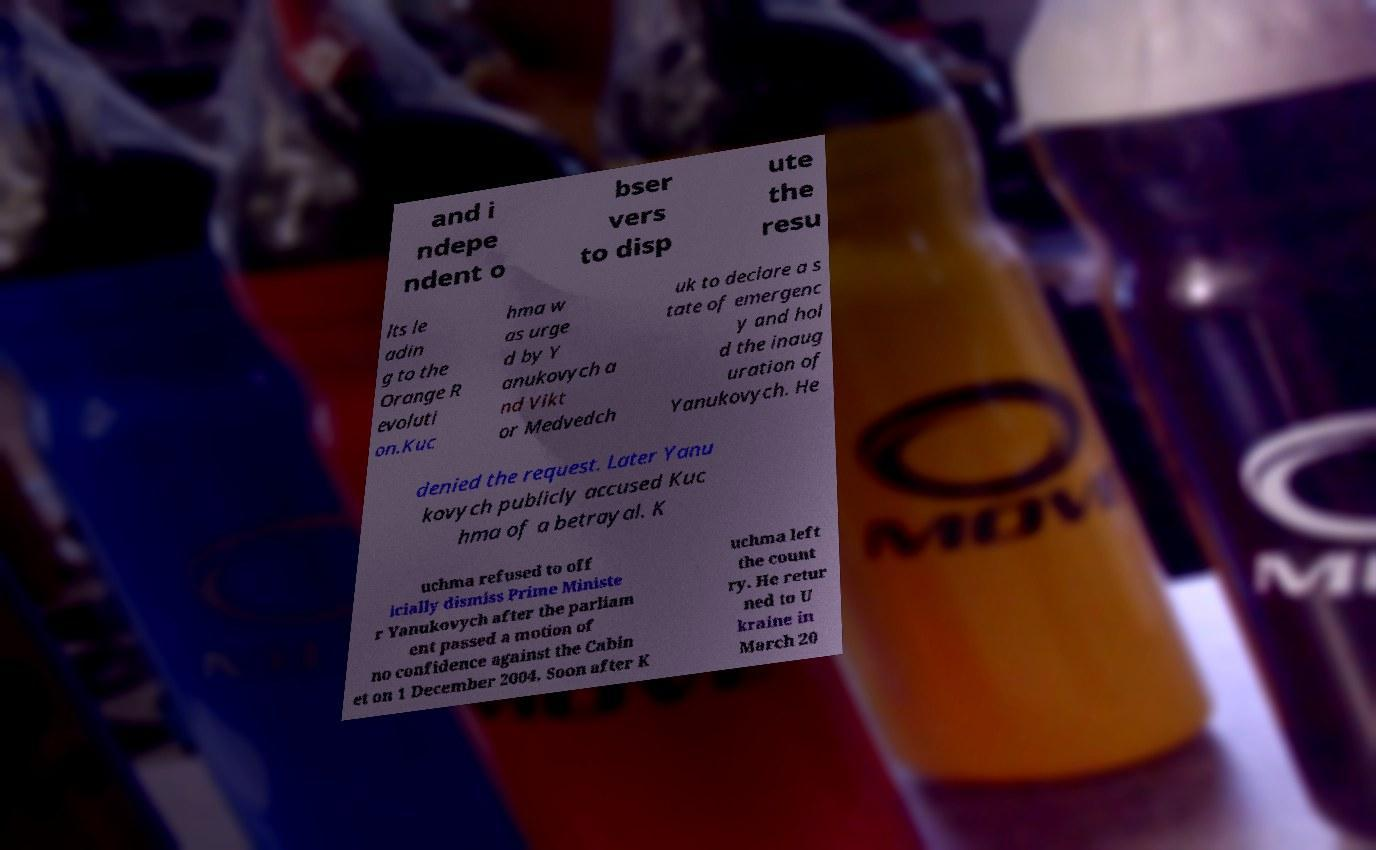Please read and relay the text visible in this image. What does it say? and i ndepe ndent o bser vers to disp ute the resu lts le adin g to the Orange R evoluti on.Kuc hma w as urge d by Y anukovych a nd Vikt or Medvedch uk to declare a s tate of emergenc y and hol d the inaug uration of Yanukovych. He denied the request. Later Yanu kovych publicly accused Kuc hma of a betrayal. K uchma refused to off icially dismiss Prime Ministe r Yanukovych after the parliam ent passed a motion of no confidence against the Cabin et on 1 December 2004. Soon after K uchma left the count ry. He retur ned to U kraine in March 20 